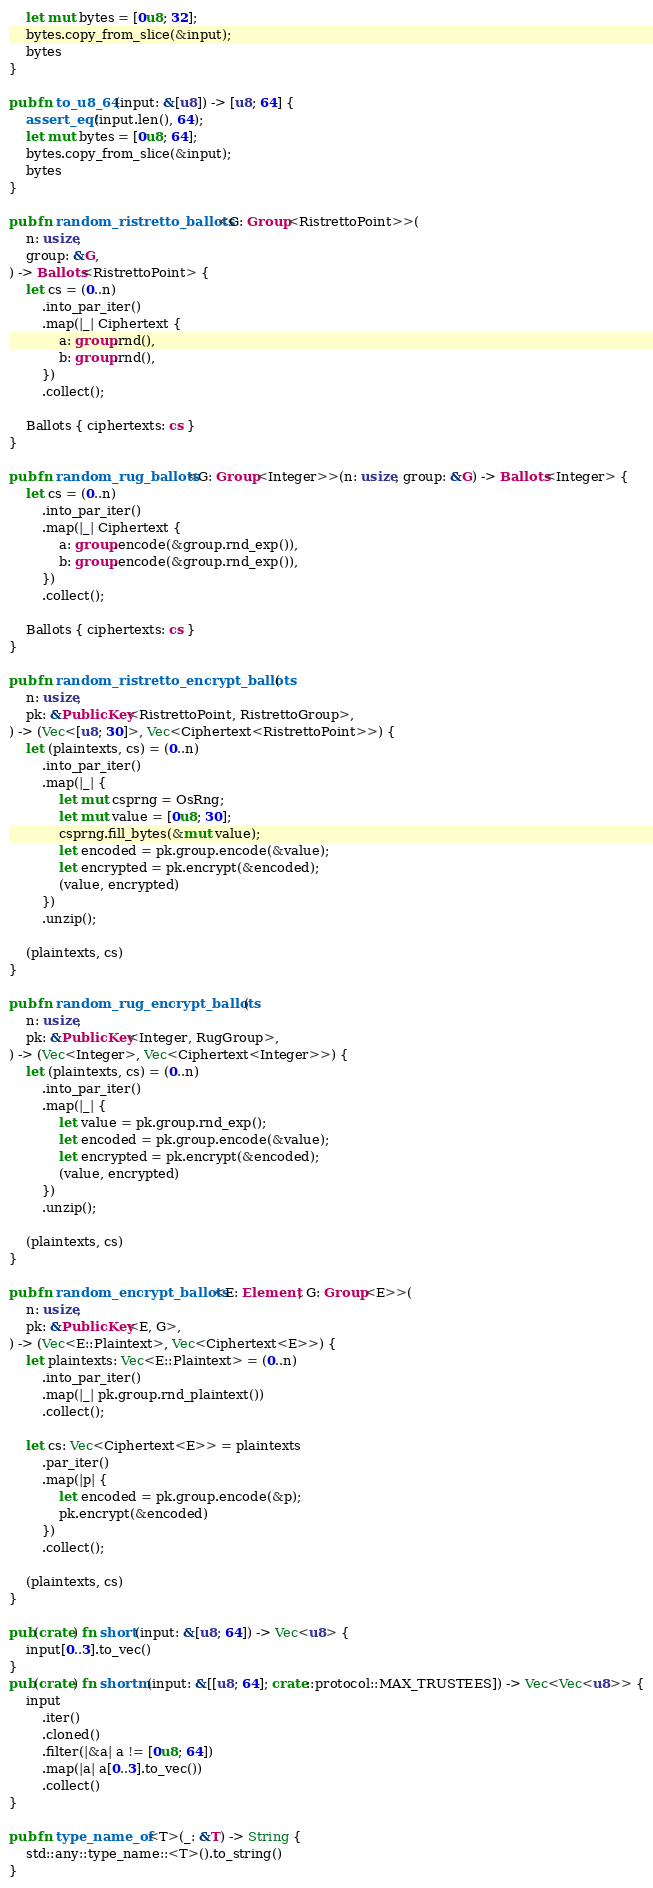Convert code to text. <code><loc_0><loc_0><loc_500><loc_500><_Rust_>    let mut bytes = [0u8; 32];
    bytes.copy_from_slice(&input);
    bytes
}

pub fn to_u8_64(input: &[u8]) -> [u8; 64] {
    assert_eq!(input.len(), 64);
    let mut bytes = [0u8; 64];
    bytes.copy_from_slice(&input);
    bytes
}

pub fn random_ristretto_ballots<G: Group<RistrettoPoint>>(
    n: usize,
    group: &G,
) -> Ballots<RistrettoPoint> {
    let cs = (0..n)
        .into_par_iter()
        .map(|_| Ciphertext {
            a: group.rnd(),
            b: group.rnd(),
        })
        .collect();

    Ballots { ciphertexts: cs }
}

pub fn random_rug_ballots<G: Group<Integer>>(n: usize, group: &G) -> Ballots<Integer> {
    let cs = (0..n)
        .into_par_iter()
        .map(|_| Ciphertext {
            a: group.encode(&group.rnd_exp()),
            b: group.encode(&group.rnd_exp()),
        })
        .collect();

    Ballots { ciphertexts: cs }
}

pub fn random_ristretto_encrypt_ballots(
    n: usize,
    pk: &PublicKey<RistrettoPoint, RistrettoGroup>,
) -> (Vec<[u8; 30]>, Vec<Ciphertext<RistrettoPoint>>) {
    let (plaintexts, cs) = (0..n)
        .into_par_iter()
        .map(|_| {
            let mut csprng = OsRng;
            let mut value = [0u8; 30];
            csprng.fill_bytes(&mut value);
            let encoded = pk.group.encode(&value);
            let encrypted = pk.encrypt(&encoded);
            (value, encrypted)
        })
        .unzip();

    (plaintexts, cs)
}

pub fn random_rug_encrypt_ballots(
    n: usize,
    pk: &PublicKey<Integer, RugGroup>,
) -> (Vec<Integer>, Vec<Ciphertext<Integer>>) {
    let (plaintexts, cs) = (0..n)
        .into_par_iter()
        .map(|_| {
            let value = pk.group.rnd_exp();
            let encoded = pk.group.encode(&value);
            let encrypted = pk.encrypt(&encoded);
            (value, encrypted)
        })
        .unzip();

    (plaintexts, cs)
}

pub fn random_encrypt_ballots<E: Element, G: Group<E>>(
    n: usize,
    pk: &PublicKey<E, G>,
) -> (Vec<E::Plaintext>, Vec<Ciphertext<E>>) {
    let plaintexts: Vec<E::Plaintext> = (0..n)
        .into_par_iter()
        .map(|_| pk.group.rnd_plaintext())
        .collect();

    let cs: Vec<Ciphertext<E>> = plaintexts
        .par_iter()
        .map(|p| {
            let encoded = pk.group.encode(&p);
            pk.encrypt(&encoded)
        })
        .collect();

    (plaintexts, cs)
}

pub(crate) fn short(input: &[u8; 64]) -> Vec<u8> {
    input[0..3].to_vec()
}
pub(crate) fn shortm(input: &[[u8; 64]; crate::protocol::MAX_TRUSTEES]) -> Vec<Vec<u8>> {
    input
        .iter()
        .cloned()
        .filter(|&a| a != [0u8; 64])
        .map(|a| a[0..3].to_vec())
        .collect()
}

pub fn type_name_of<T>(_: &T) -> String {
    std::any::type_name::<T>().to_string()
}
</code> 